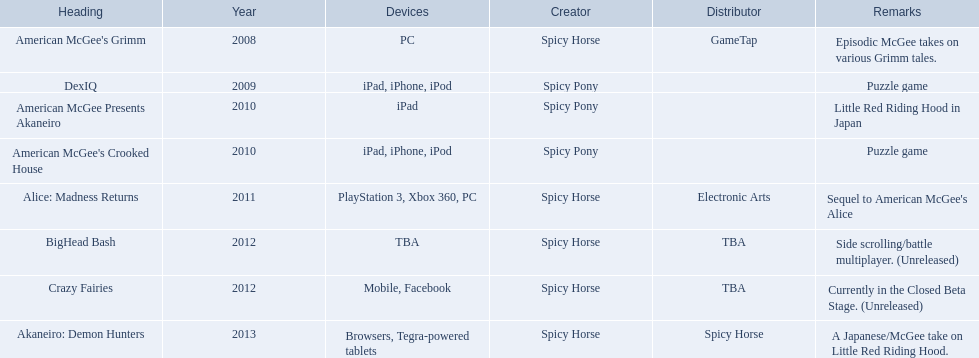What are all the titles of games published? American McGee's Grimm, DexIQ, American McGee Presents Akaneiro, American McGee's Crooked House, Alice: Madness Returns, BigHead Bash, Crazy Fairies, Akaneiro: Demon Hunters. What are all the names of the publishers? GameTap, , , , Electronic Arts, TBA, TBA, Spicy Horse. What is the published game title that corresponds to electronic arts? Alice: Madness Returns. 